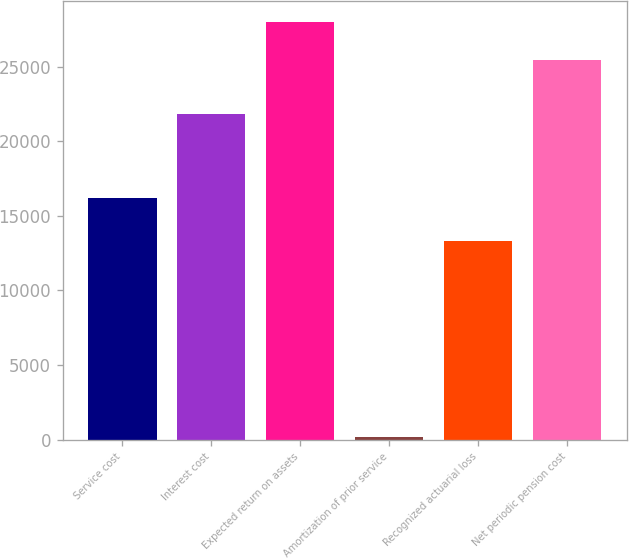Convert chart. <chart><loc_0><loc_0><loc_500><loc_500><bar_chart><fcel>Service cost<fcel>Interest cost<fcel>Expected return on assets<fcel>Amortization of prior service<fcel>Recognized actuarial loss<fcel>Net periodic pension cost<nl><fcel>16231<fcel>21850<fcel>28022.2<fcel>192<fcel>13322<fcel>25467<nl></chart> 